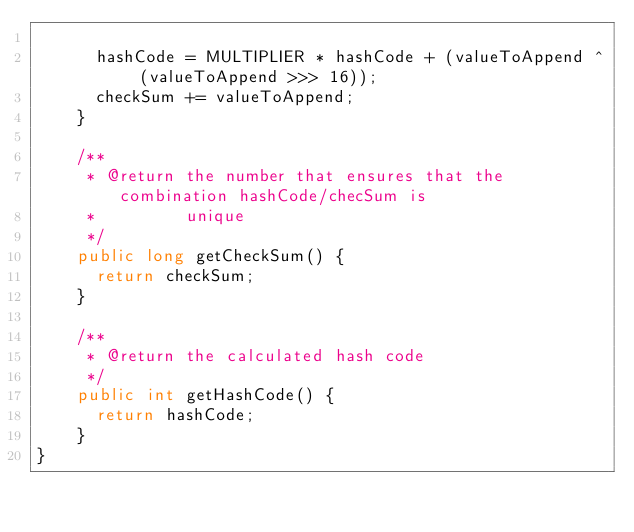Convert code to text. <code><loc_0><loc_0><loc_500><loc_500><_Java_>
	    hashCode = MULTIPLIER * hashCode + (valueToAppend ^ (valueToAppend >>> 16));
	    checkSum += valueToAppend;
	  }

	  /**
	   * @return the number that ensures that the combination hashCode/checSum is
	   *         unique
	   */
	  public long getCheckSum() {
	    return checkSum;
	  }

	  /**
	   * @return the calculated hash code
	   */
	  public int getHashCode() {
	    return hashCode;
	  }
}
</code> 